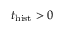<formula> <loc_0><loc_0><loc_500><loc_500>t _ { h i s t } > 0</formula> 